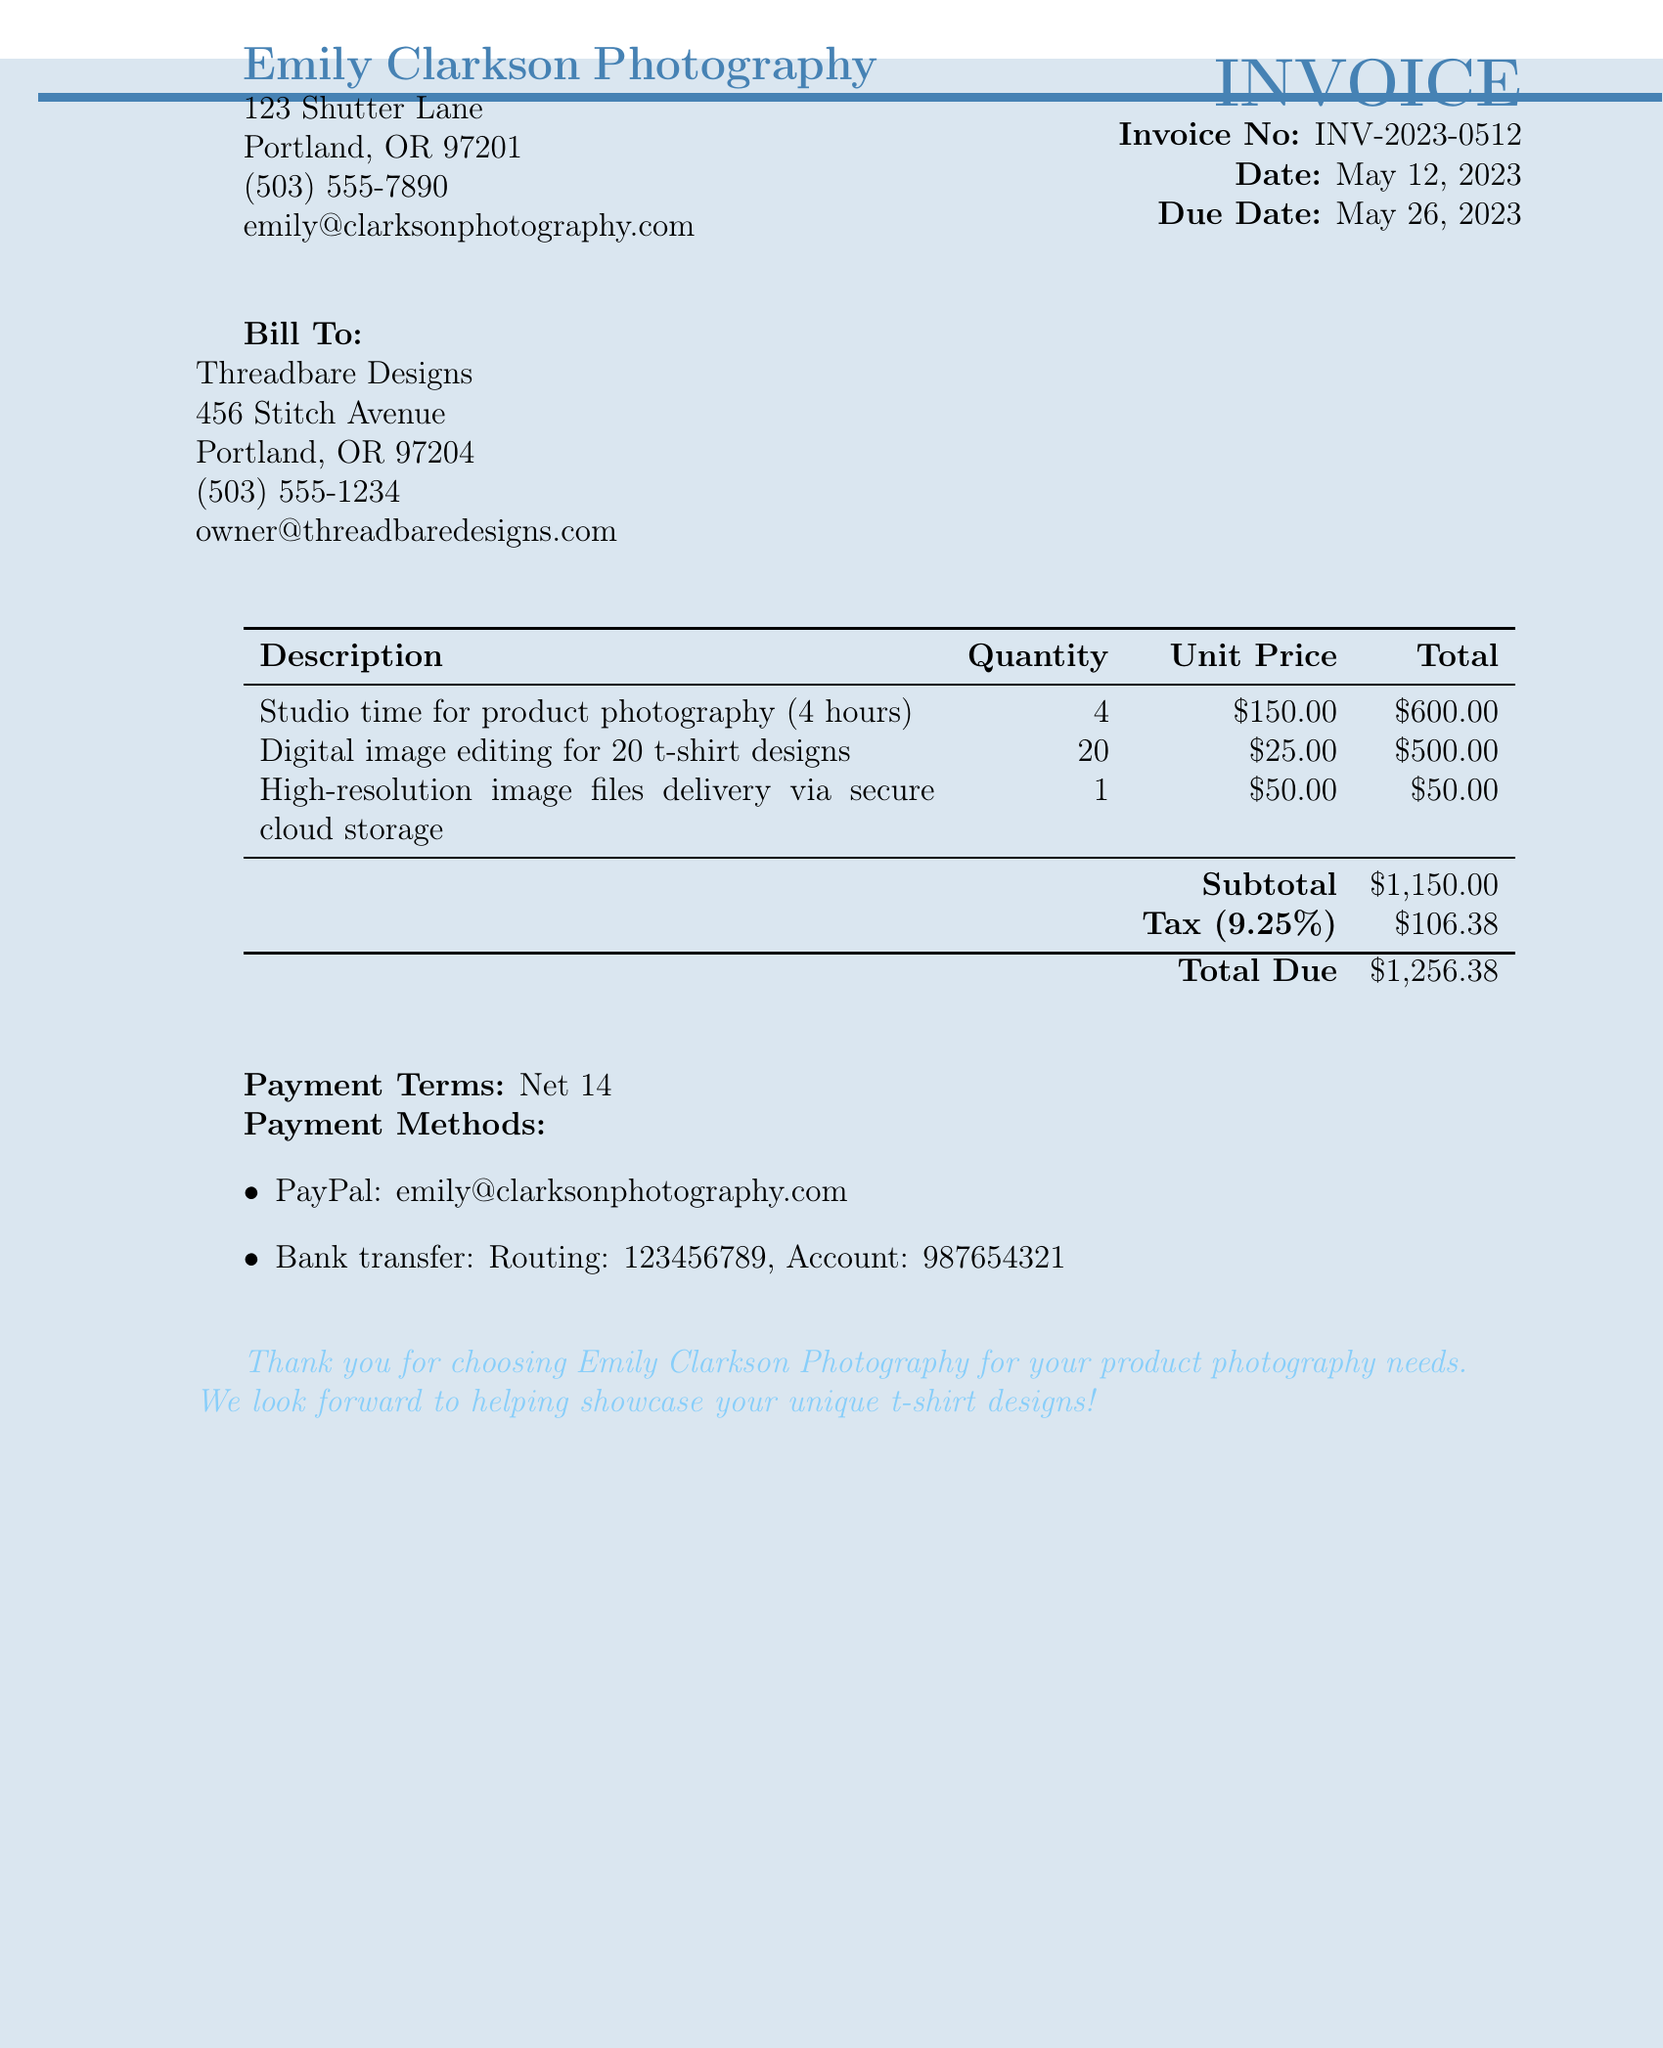what is the invoice number? The invoice number is listed clearly in the document as part of the heading.
Answer: INV-2023-0512 what is the due date? The due date is specified in the document, indicating when payment is expected.
Answer: May 26, 2023 who is the photographer? The photographer's name is provided in the contact information at the top of the invoice.
Answer: Emily Clarkson Photography what is the subtotal amount? The subtotal amount is the sum of the service totals without tax, mentioned in the billing section.
Answer: $1,150.00 how many hours of studio time were billed? The hours of studio time are detailed in the description of the service provided.
Answer: 4 hours what is the tax rate? The tax rate is clearly stated in the section detailing tax calculations.
Answer: 9.25% what is the total amount due? The total amount due is the final sum that includes subtotal and tax, provided at the bottom of the invoice.
Answer: $1,256.38 what payment methods are accepted? Payment methods are listed in the document as part of the invoicing details.
Answer: PayPal and Bank transfer what is the client's email address? The client's email address is provided in the client information section of the invoice.
Answer: owner@threadbaredesigns.com 